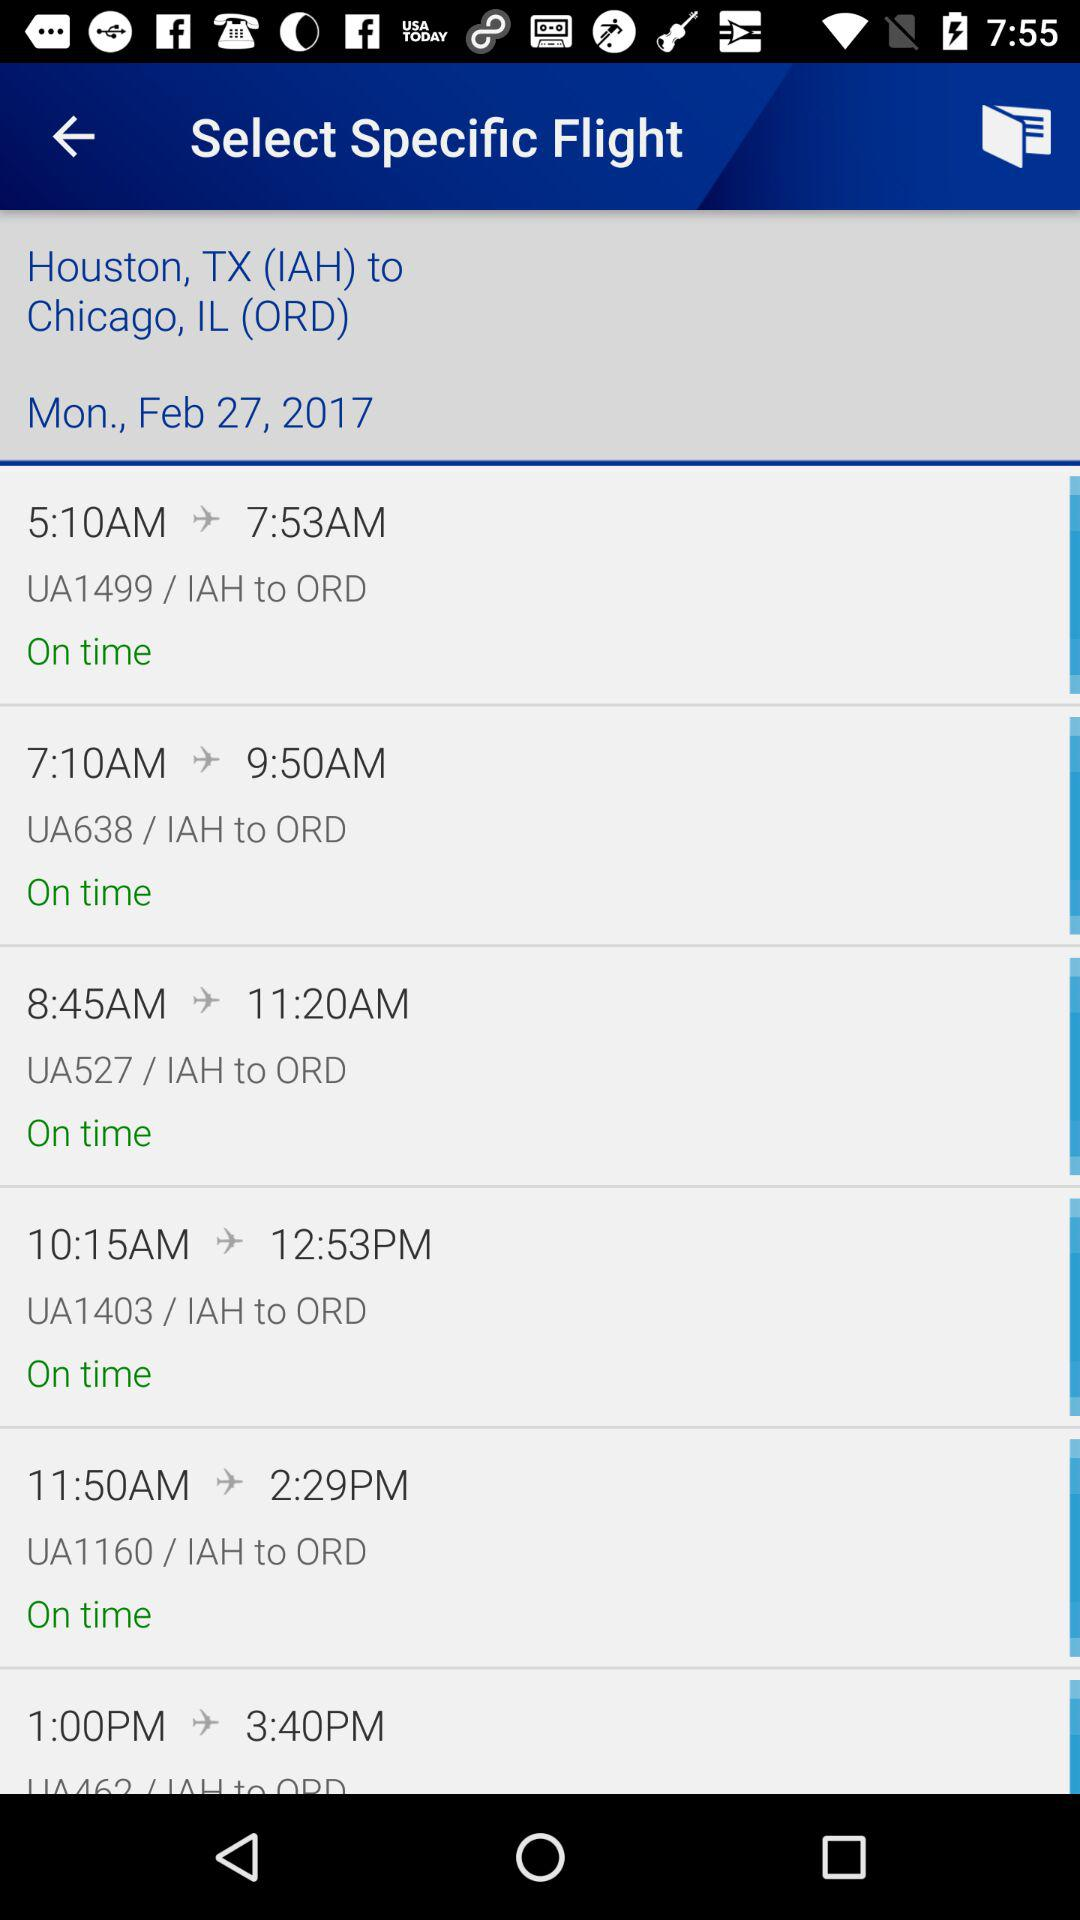What is the date and day for the fight? The date and day for the fight are Monday, February 27, 2017. 